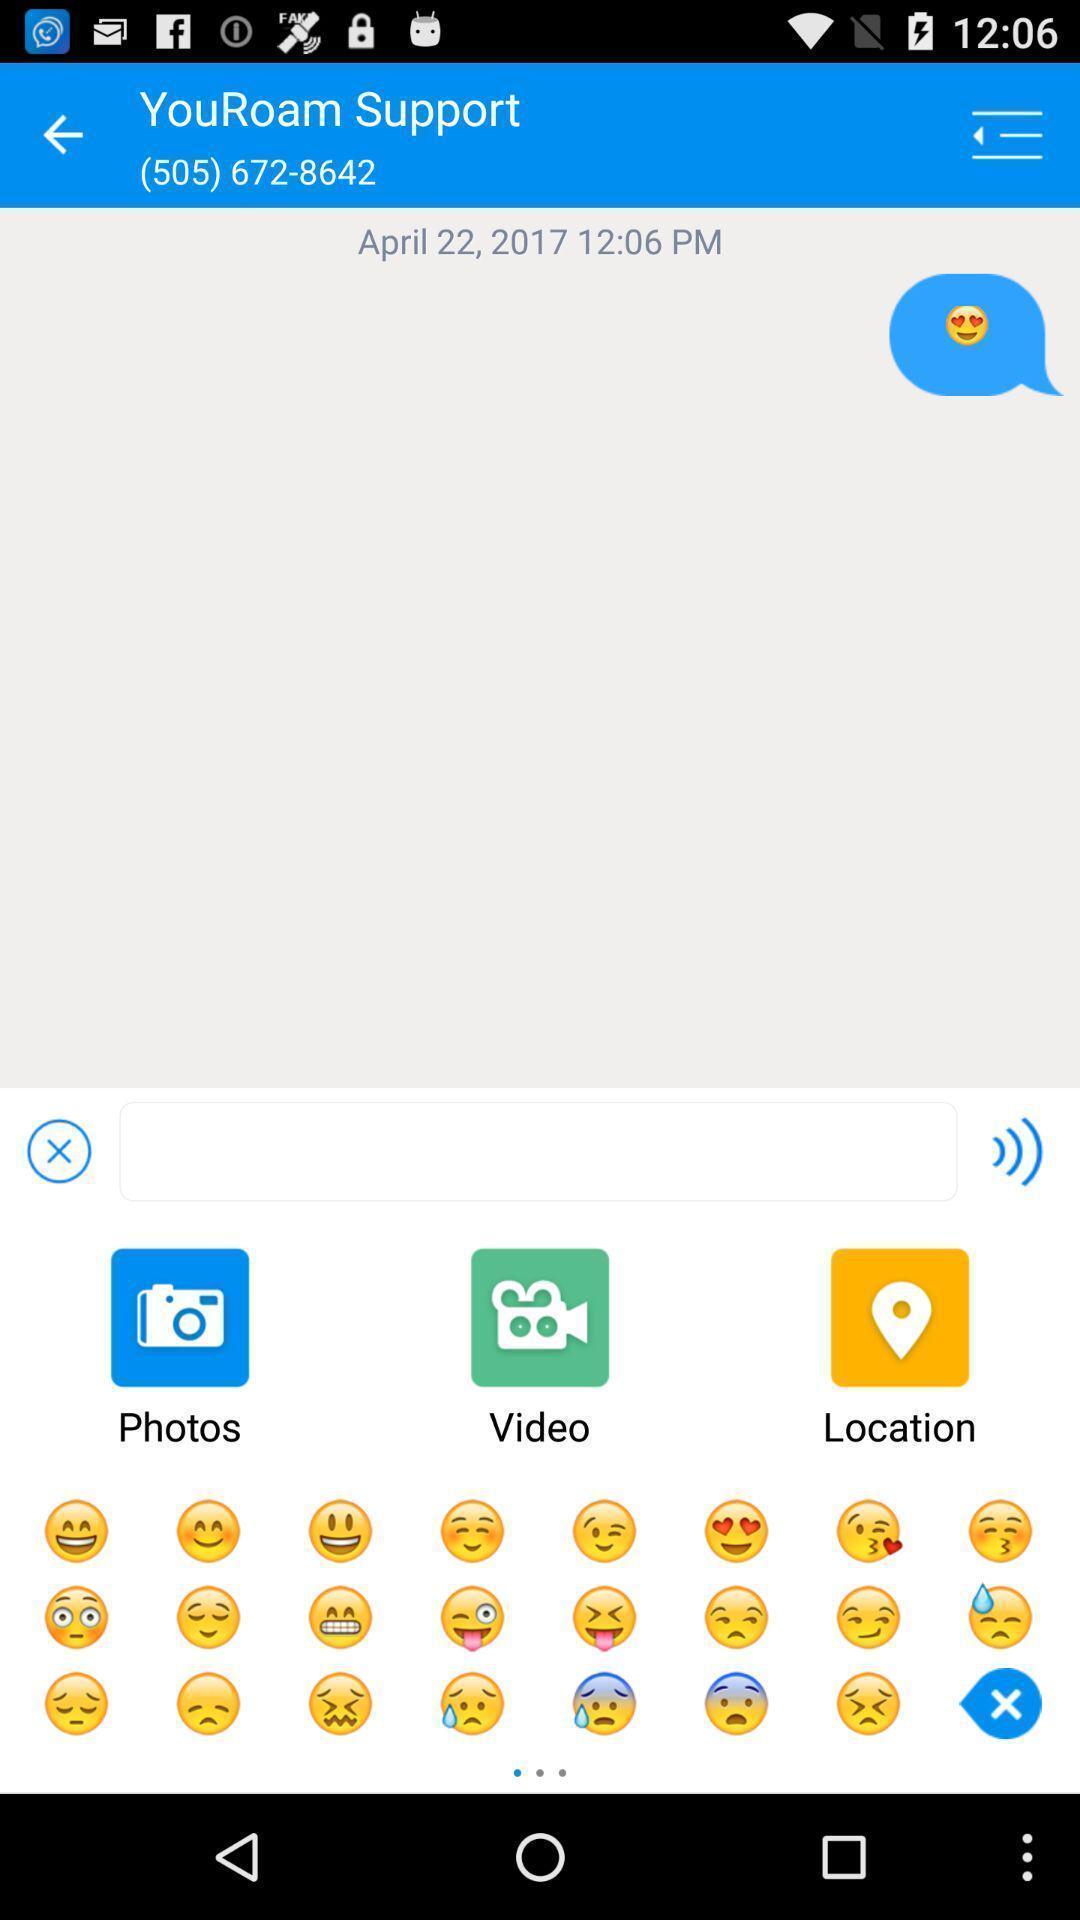Describe the key features of this screenshot. Screen page displaying multiple options in social application. 